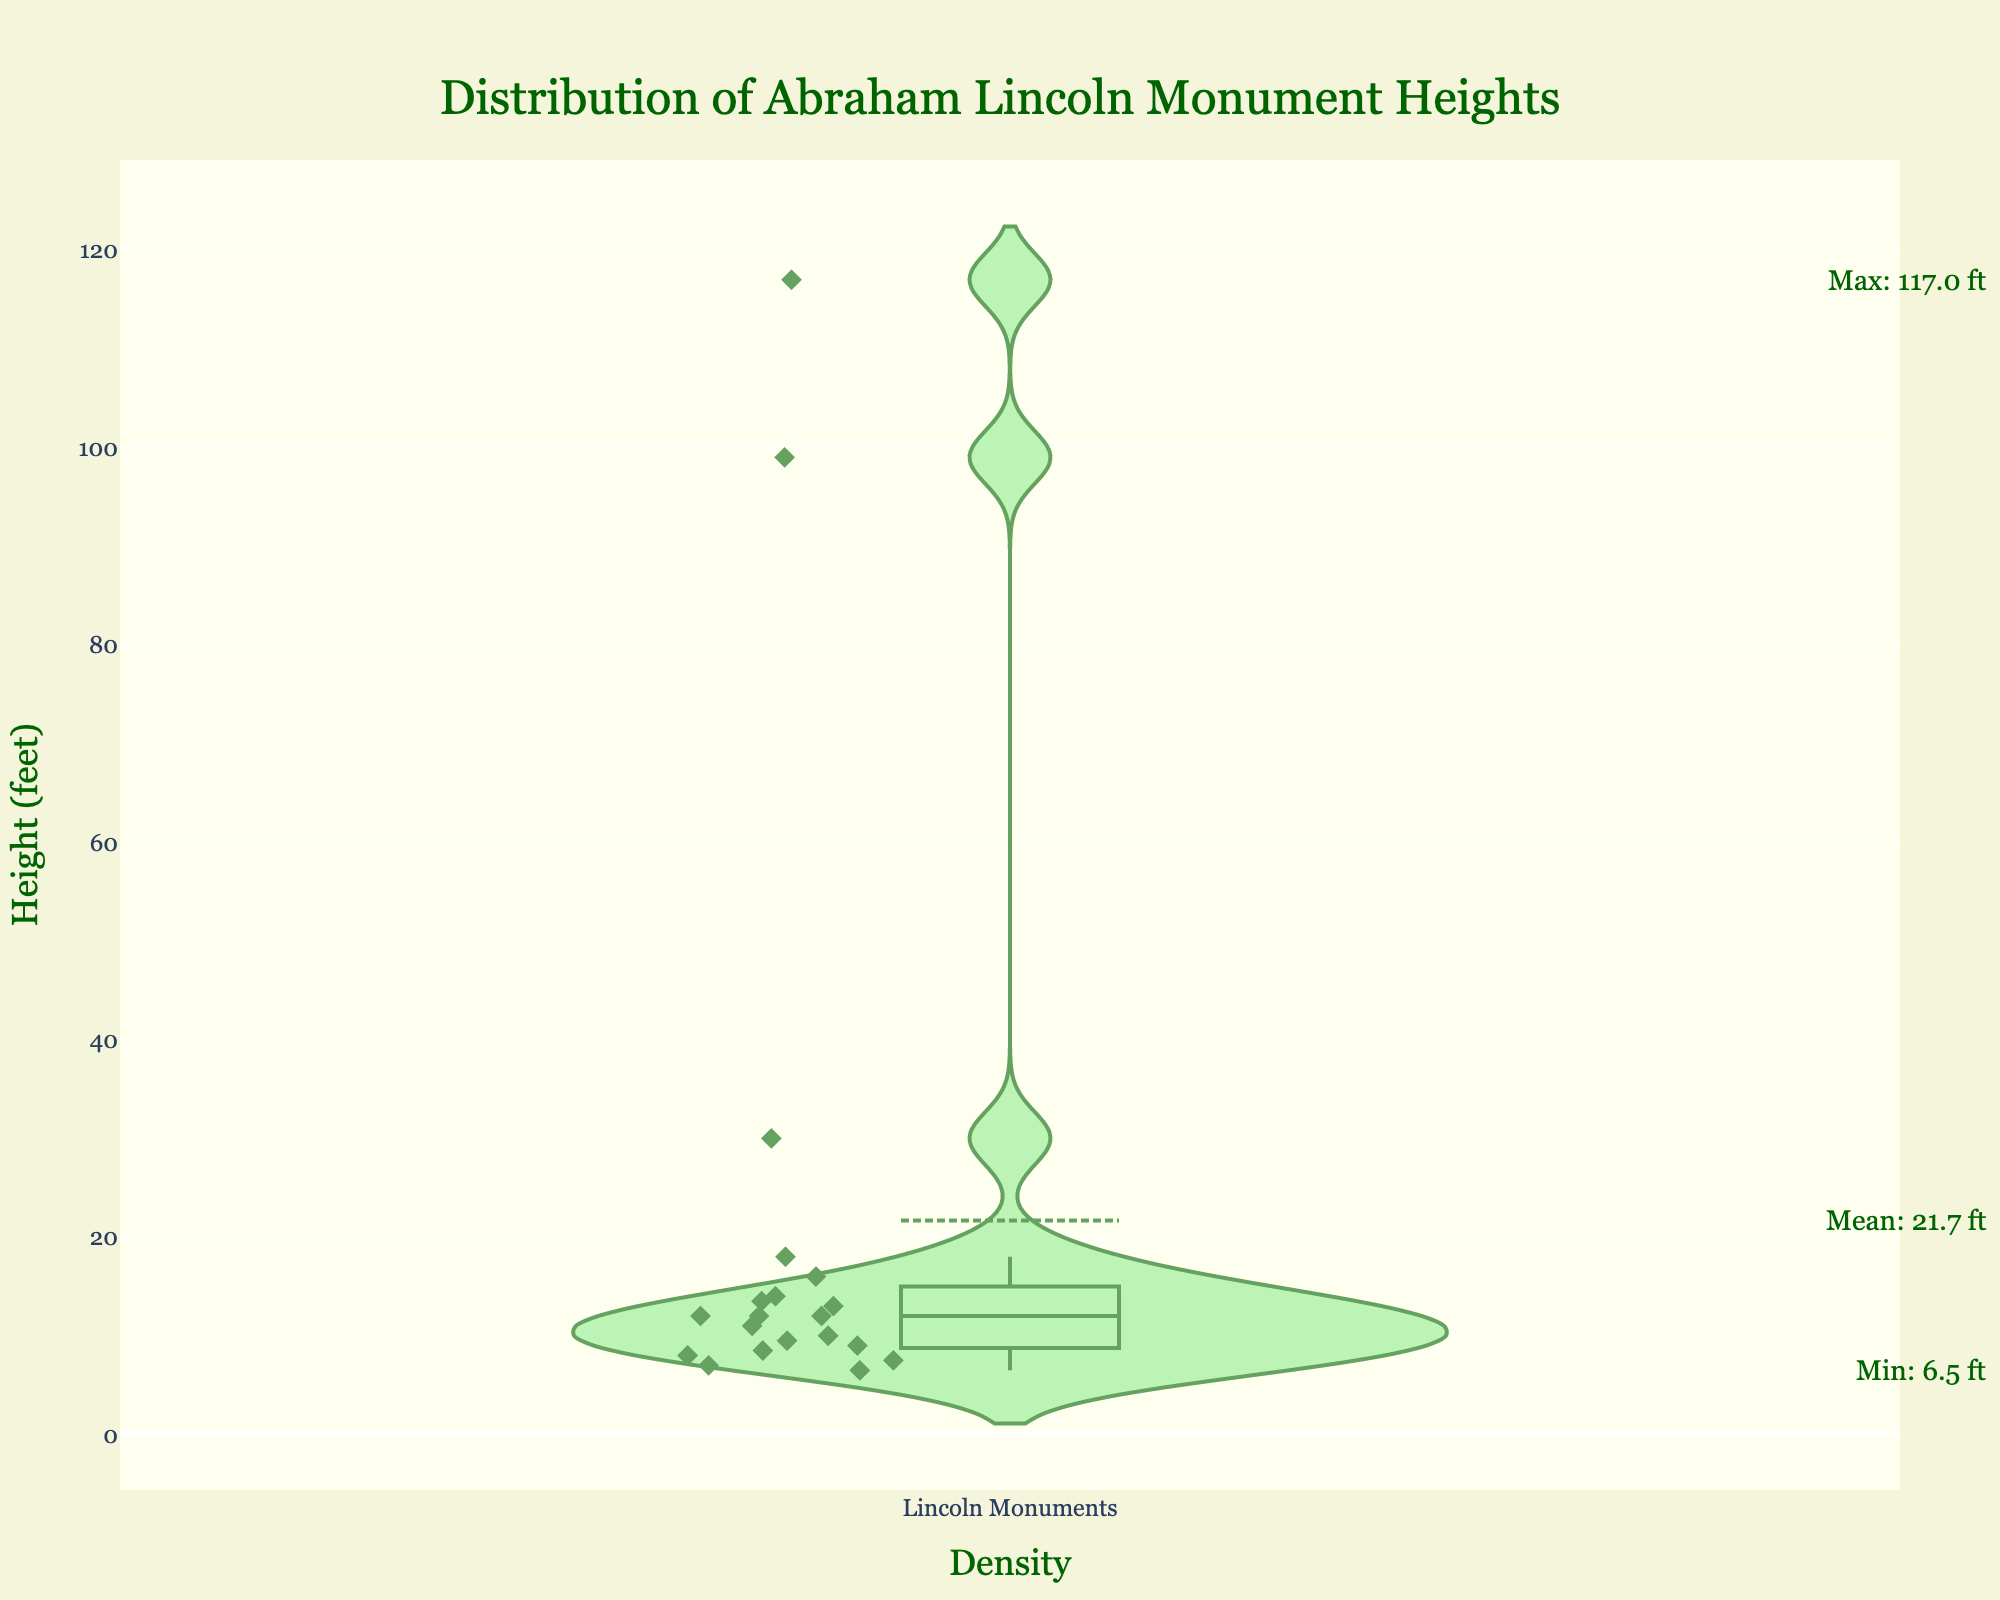What is the title of the figure? The title is typically displayed at the top of the figure. In this case, it reads "Distribution of Abraham Lincoln Monument Heights."
Answer: Distribution of Abraham Lincoln Monument Heights What is the minimum height of an Abraham Lincoln monument? The minimum height is marked by the annotation on the y-axis, which is specified as the lowest data point on the violin plot.
Answer: 6.5 feet What is the maximum height of an Abraham Lincoln monument? The maximum height is indicated by the annotation on the y-axis, identified as the highest data point on the violin plot.
Answer: 117 feet What is the mean height of the Abraham Lincoln monuments? The mean height is provided in an annotation next to the y-axis.
Answer: 23.0 feet How many data points represent the heights of Abraham Lincoln monuments? The number of data points is visualized by the individual markers ('diamond' symbols) along the violin plot. Each marker represents one data point. By counting, there are 20 markers.
Answer: 20 Which monument is the tallest, and how tall is it? The tallest monument is the one with the maximum y-axis height annotation. The title and height are combined to provide the answer.
Answer: Lincoln Tomb (Springfield), 117 feet What are the median and interquartile range (IQR) of the monument heights shown in the figure? The median is the middle value visible in the plot's box-and-whisker component, while the IQR is the range between the first and third quartiles, identified as the edges of the box.
Answer: Median: 12 feet, IQR: 9.5-18 feet How does the height of the Lincoln Memorial compare to the mean height of all monuments? To compare, identify the Lincoln Memorial's height, which is 99 feet, and compare it to the mean height annotation of 23.0 feet on the plot. The Lincoln Memorial is significantly taller.
Answer: Lincoln Memorial is significantly taller than the mean Which city has the smallest monument dedicated to Abraham Lincoln, and what is its height? Find the smallest height indication on the plot and match it to the corresponding city, stated in the dataset as 6.5 feet for Lincoln-Tallman House statue in Janesville.
Answer: Janesville, 6.5 feet What proportion of monuments are taller than the mean height? By counting how many markers are above the mean line (23.0 feet) in the violin plot and dividing by the total number of data points, this proportion can be determined. There are 4 markers above the mean out of 20. The proportion is \(4/20 = 0.2\).
Answer: 20% 